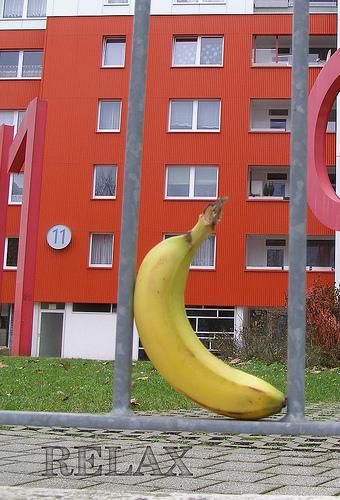What unique feature of the image makes the banana appear unusual? The angle of the photograph makes the banana look huge. What type of building is in the picture and what color is it? The building is an orange, multi-story structure. Describe the placement of the banana and what it interacts with. The banana is positioned between two poles, leaning against the bars of a metal fence. Identify an object found on one of the balconies. There is a satellite dish on one of the balconies. Describe the colors and conditions of the leaves on the grass. The grass is green, and there are dry, brown leaves scattered throughout the lawn. Point out a sculpture in the image and its color. There is a large red sculpture of the number 1. Identify the color and condition of the banana in the image. The banana is yellow and ripe. Mention a detail about a window or door of the building. One of the windows has white, patterned curtains. 